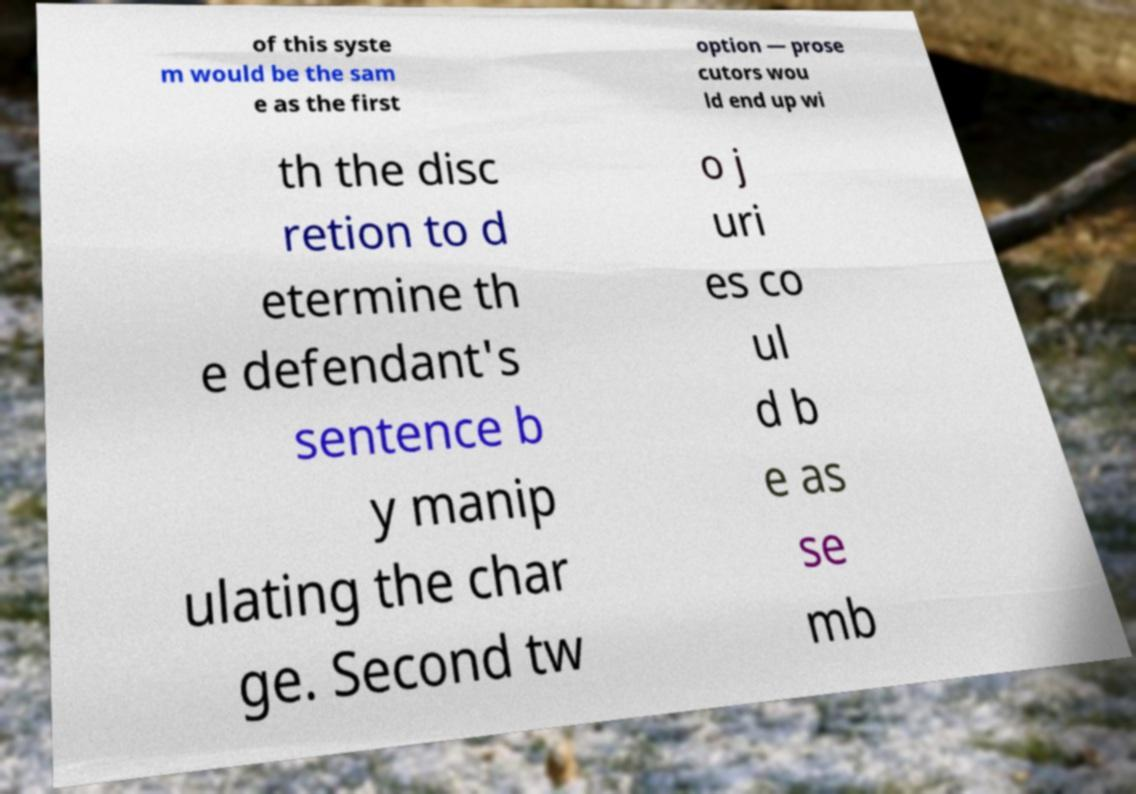Can you read and provide the text displayed in the image?This photo seems to have some interesting text. Can you extract and type it out for me? of this syste m would be the sam e as the first option — prose cutors wou ld end up wi th the disc retion to d etermine th e defendant's sentence b y manip ulating the char ge. Second tw o j uri es co ul d b e as se mb 